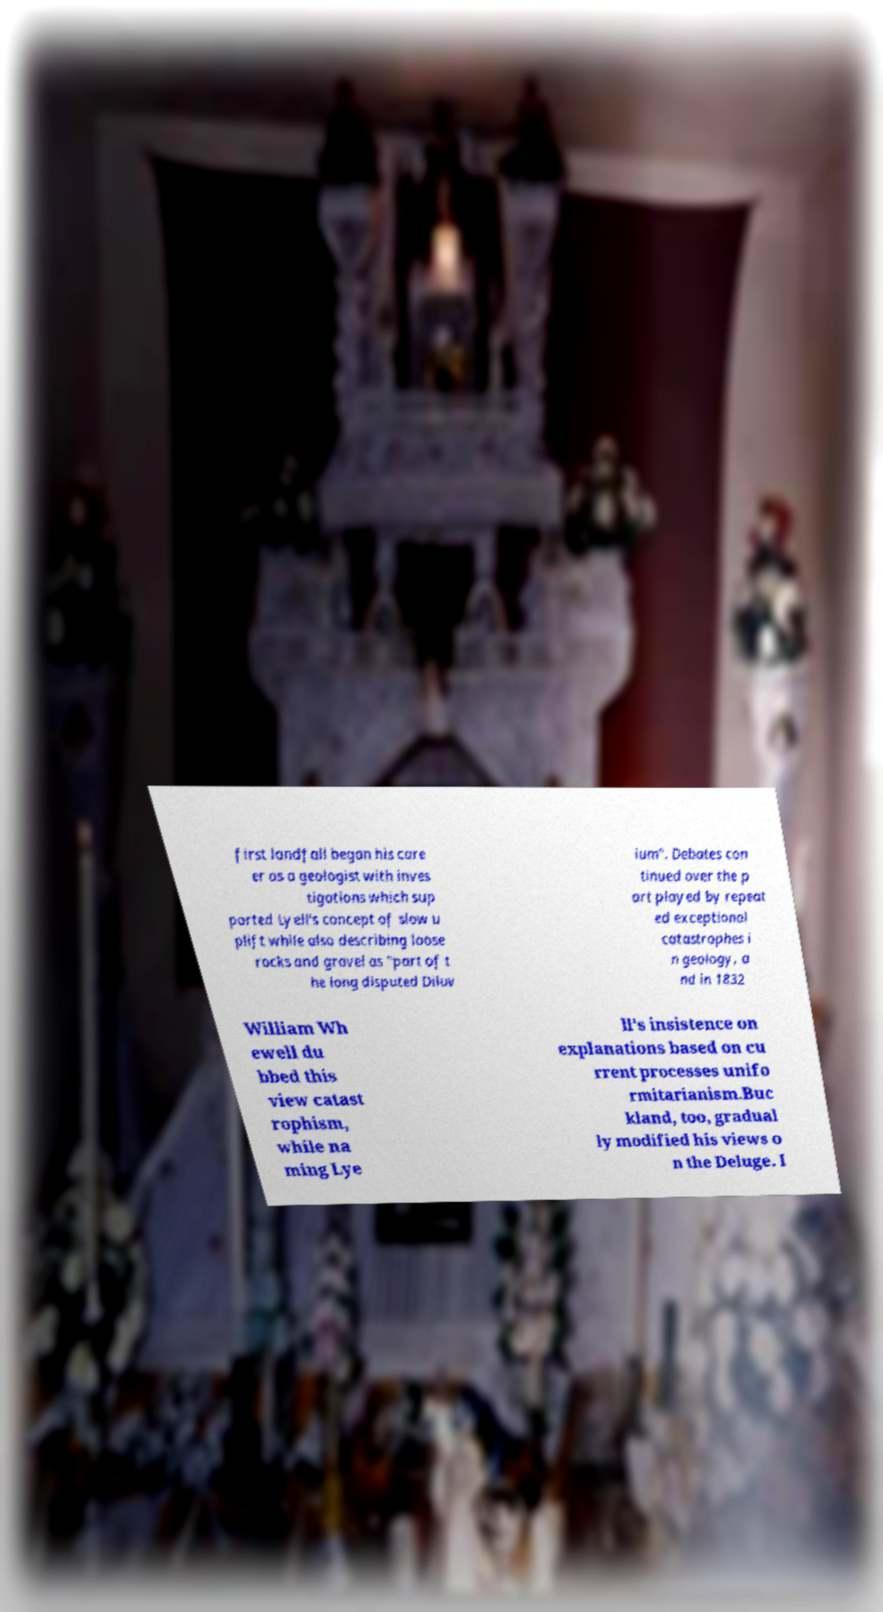What messages or text are displayed in this image? I need them in a readable, typed format. first landfall began his care er as a geologist with inves tigations which sup ported Lyell's concept of slow u plift while also describing loose rocks and gravel as "part of t he long disputed Diluv ium". Debates con tinued over the p art played by repeat ed exceptional catastrophes i n geology, a nd in 1832 William Wh ewell du bbed this view catast rophism, while na ming Lye ll's insistence on explanations based on cu rrent processes unifo rmitarianism.Buc kland, too, gradual ly modified his views o n the Deluge. I 